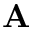Convert formula to latex. <formula><loc_0><loc_0><loc_500><loc_500>{ A }</formula> 